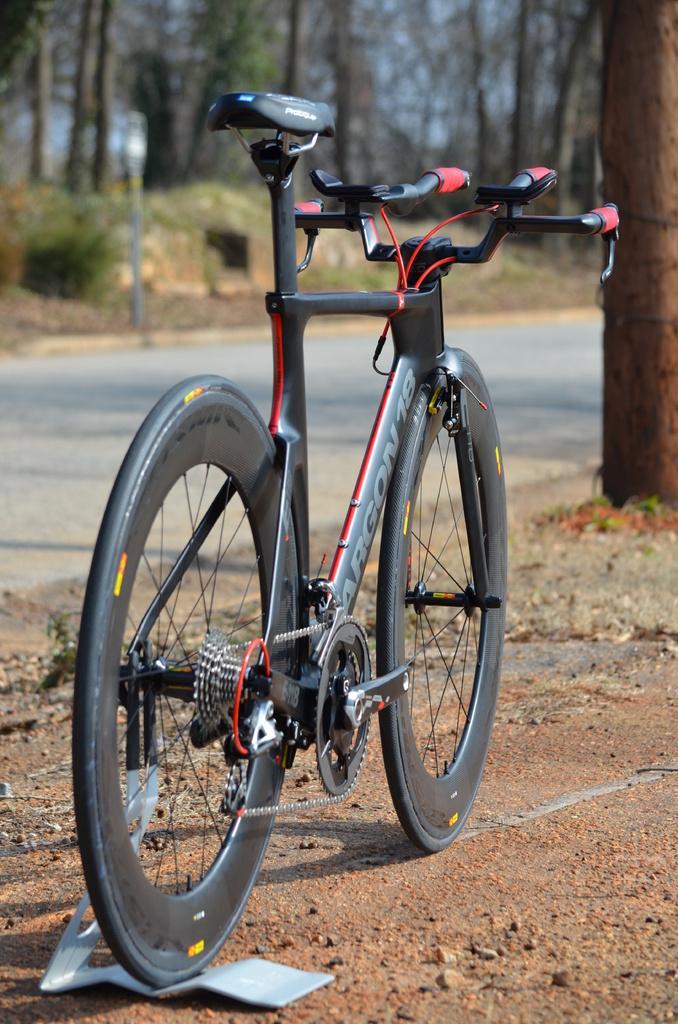Could you give a brief overview of what you see in this image? In the center of the image, we can see a bicycle on the stand and in the background, there are trees and there is a pole. At the bottom, there is a road and ground. 